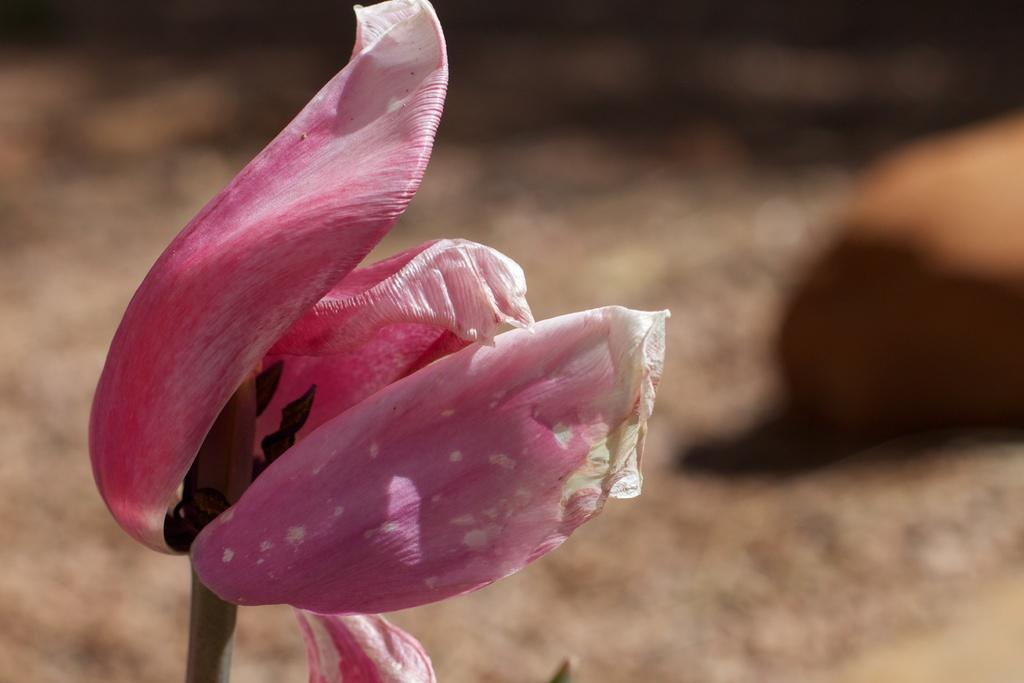What type of flower is in the image? There is a pink color flower in the image. Can you describe the background of the image? The background of the image is blurred. What suggestion does the woman in the image give to the viewer? There is no woman present in the image, so it is not possible to answer a question about her suggestion. 